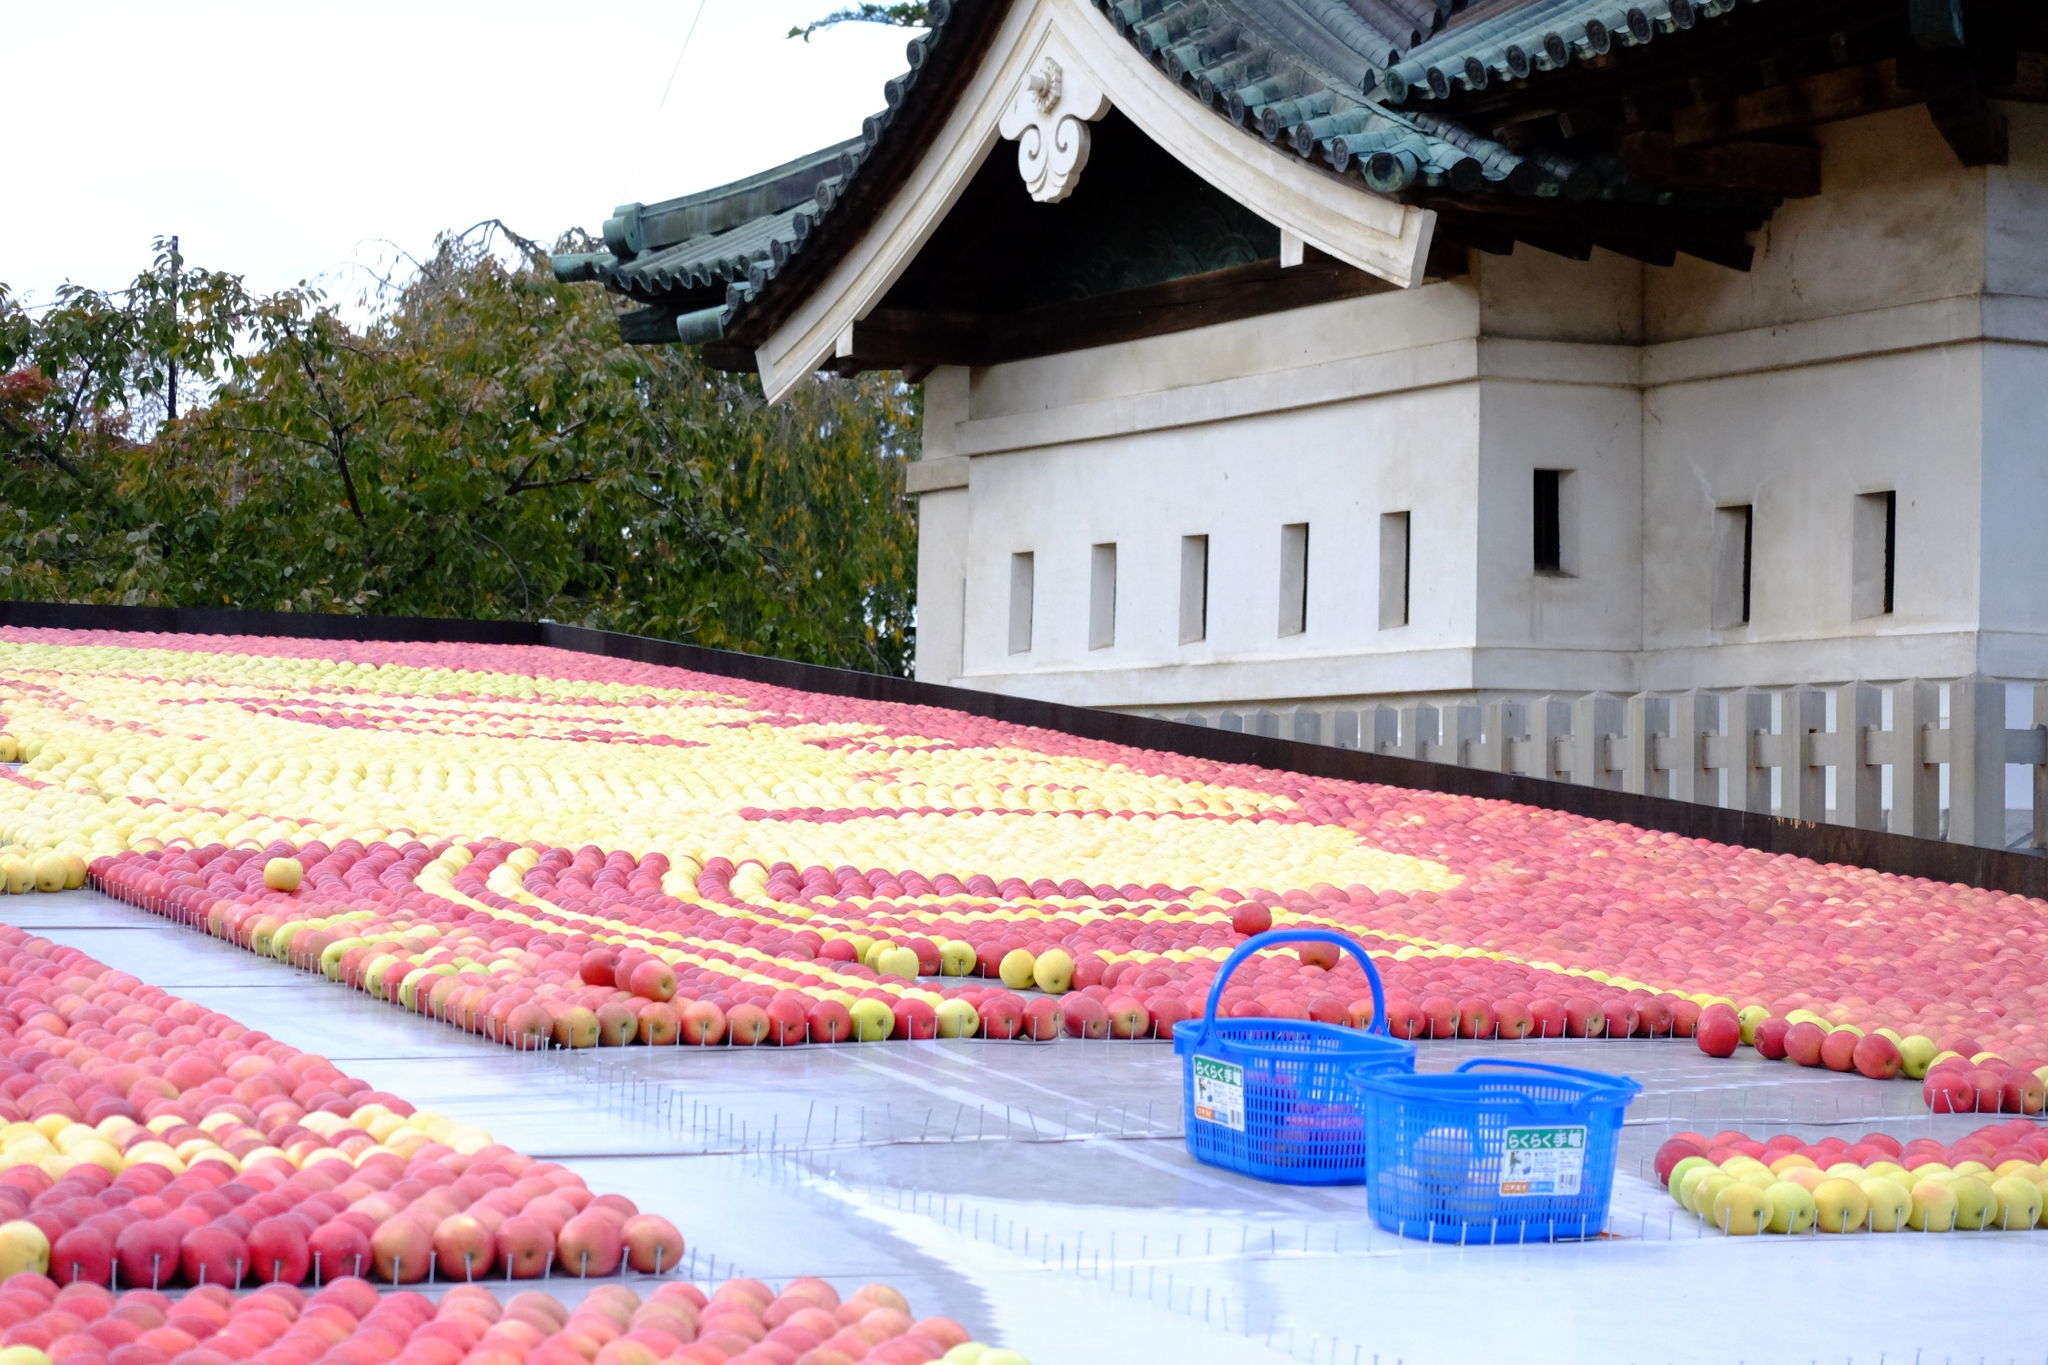What's happening in the scene?
 The image captures a vibrant scene in front of a traditional Japanese temple. The temple, with its green roof and white walls, provides a serene backdrop to the lively display of fruits in the foreground. Rows of red and yellow apples add a splash of color to the scene, their hues contrasting beautifully with the blue basket that sits prominently in the foreground. A wooden fence, perhaps a boundary of the temple grounds, frames the lower edge of the image. The perspective of the image is from the side, allowing both the fruit display and the temple to share the limelight. The image is a harmonious blend of nature's bounty and architectural elegance. 